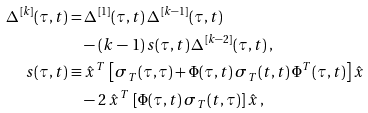<formula> <loc_0><loc_0><loc_500><loc_500>\Delta ^ { \, [ k ] } ( \tau , t ) = & \, \Delta ^ { \, [ 1 ] } ( \tau , t ) \, \Delta ^ { \, [ k - 1 ] } ( \tau , t ) \\ & - ( k \, - \, 1 ) \, s ( \tau , t ) \, \Delta ^ { \, [ k - 2 ] } ( \tau , t ) \, , \\ s ( \tau , t ) \equiv & \, \hat { x } ^ { \, T } \, \left [ \sigma _ { \, T } ( \tau , \tau ) + \Phi ( \tau , t ) \, \sigma _ { \, T } ( t , t ) \, \Phi ^ { T } ( \tau , t ) \right ] \hat { x } \\ & - 2 \, \hat { x } ^ { \, T } \, \left [ \Phi ( \tau , t ) \, \sigma _ { \, T } ( t , \tau ) \right ] \hat { x } \, ,</formula> 